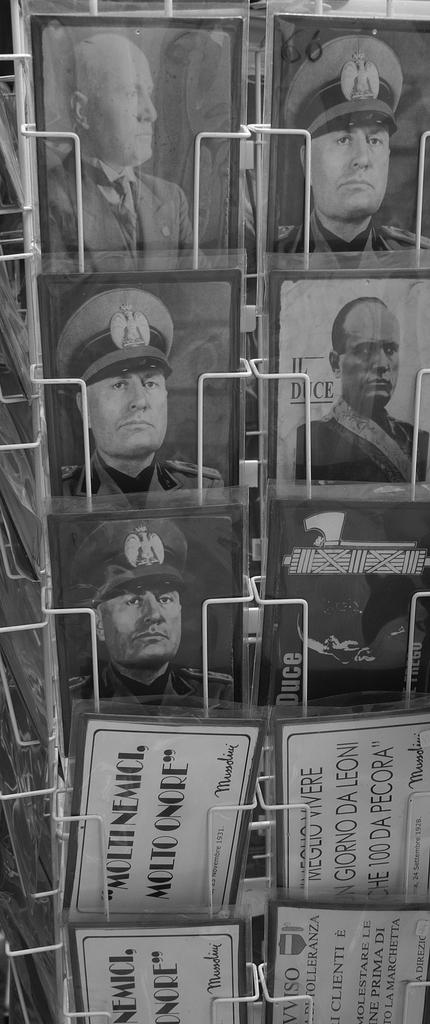What is the color scheme of the image? The image is black and white. What objects are attached to the metal stand? There are photo frames attached to a metal stand. What can be seen at the bottom of the image? There are boards at the bottom of the image. What is written or depicted on the boards? Text is visible on the boards. How many guitars are leaning against the wall in the image? There are no guitars present in the image. What is the size of the floor in the image? The image does not provide information about the size of the floor, as it is a photograph and not a floor plan. 